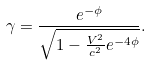<formula> <loc_0><loc_0><loc_500><loc_500>\gamma = \frac { e ^ { - \phi } } { \sqrt { 1 - \frac { V ^ { 2 } } { c ^ { 2 } } e ^ { - 4 \phi } } } .</formula> 